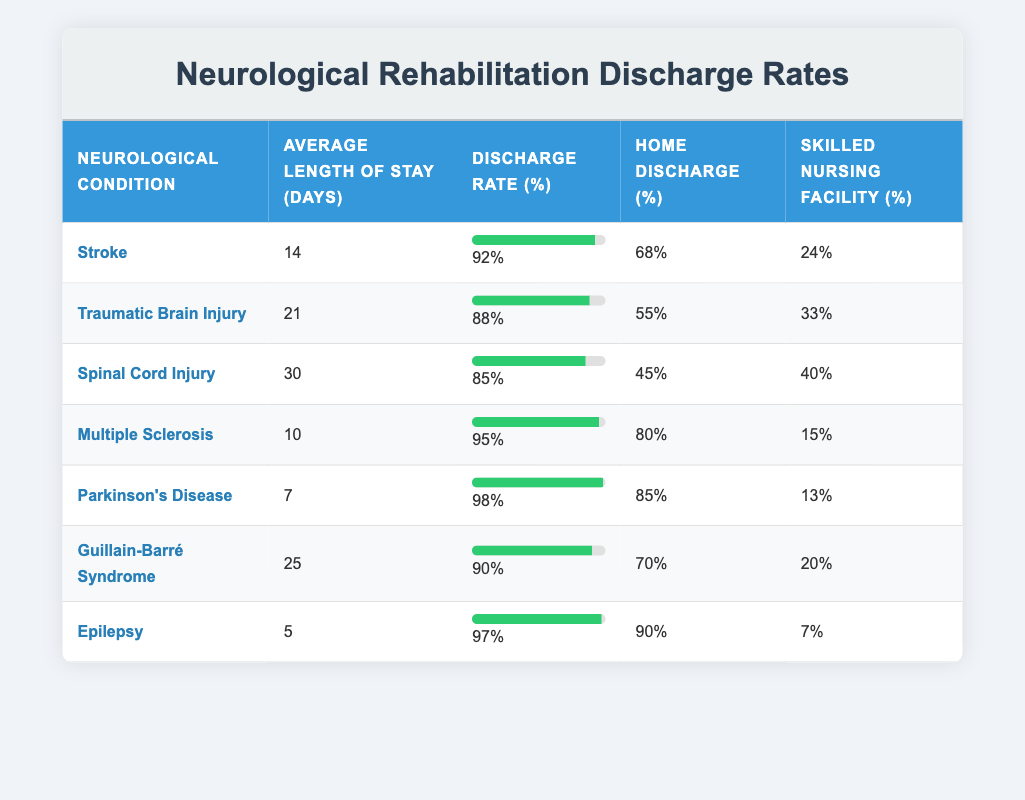What is the discharge rate for patients with Parkinson's Disease? The table clearly states that the discharge rate for Parkinson's Disease is 98%. Hence, I can directly reference this information from the table.
Answer: 98% What neurological condition has the highest average length of stay? Looking at the "Average Length of Stay (days)" column, Spinal Cord Injury has the highest value at 30 days. I compare all values in that column to find the maximum.
Answer: Spinal Cord Injury What is the percentage of patients discharged to skilled nursing facilities for Epilepsy? The table indicates a skilled nursing facility discharge percentage of 7% for Epilepsy, directly referable from the relevant row.
Answer: 7% Which condition has the lowest home discharge percentage? By examining the "Home Discharge (%)" column, Spinal Cord Injury has the lowest percentage at 45%. I can compare all values in that column to identify the minimum.
Answer: Spinal Cord Injury What is the average discharge rate for all conditions listed? The discharge rates are: 92, 88, 85, 95, 98, 90, and 97. To find the average, I sum these values (92 + 88 + 85 + 95 + 98 + 90 + 97 = 665) and then divide by the number of conditions (7). Thus, the average is 665 / 7 = 95.
Answer: 95 Is the discharge rate for Multiple Sclerosis higher than that for Traumatic Brain Injury? The discharge rate for Multiple Sclerosis is 95% and for Traumatic Brain Injury is 88%. Since 95% is greater than 88%, it is confirmed that Multiple Sclerosis has a higher discharge rate.
Answer: Yes If a patient has a stroke, is it more likely they will be discharged home than to a skilled nursing facility? The home discharge percentage for strokes is 68%, whereas skilled nursing facility discharge is 24%. Since 68% is greater than 24%, it is more likely for stroke patients to go home.
Answer: Yes What is the difference in discharge rates between patients with Guillain-Barré Syndrome and Epilepsy? Guillain-Barré Syndrome has a discharge rate of 90%, while Epilepsy has a discharge rate of 97%. The difference is calculated as 97 - 90 = 7. Thus, the discharge rate for Epilepsy is higher.
Answer: 7 How many conditions have a home discharge percentage of 70% or higher? By reviewing the "Home Discharge (%)" column, the conditions with 70% or higher are: Stroke (68%), Multiple Sclerosis (80%), and Parkinson's Disease (85%), confirming that there are four conditions that meet the criteria.
Answer: 4 